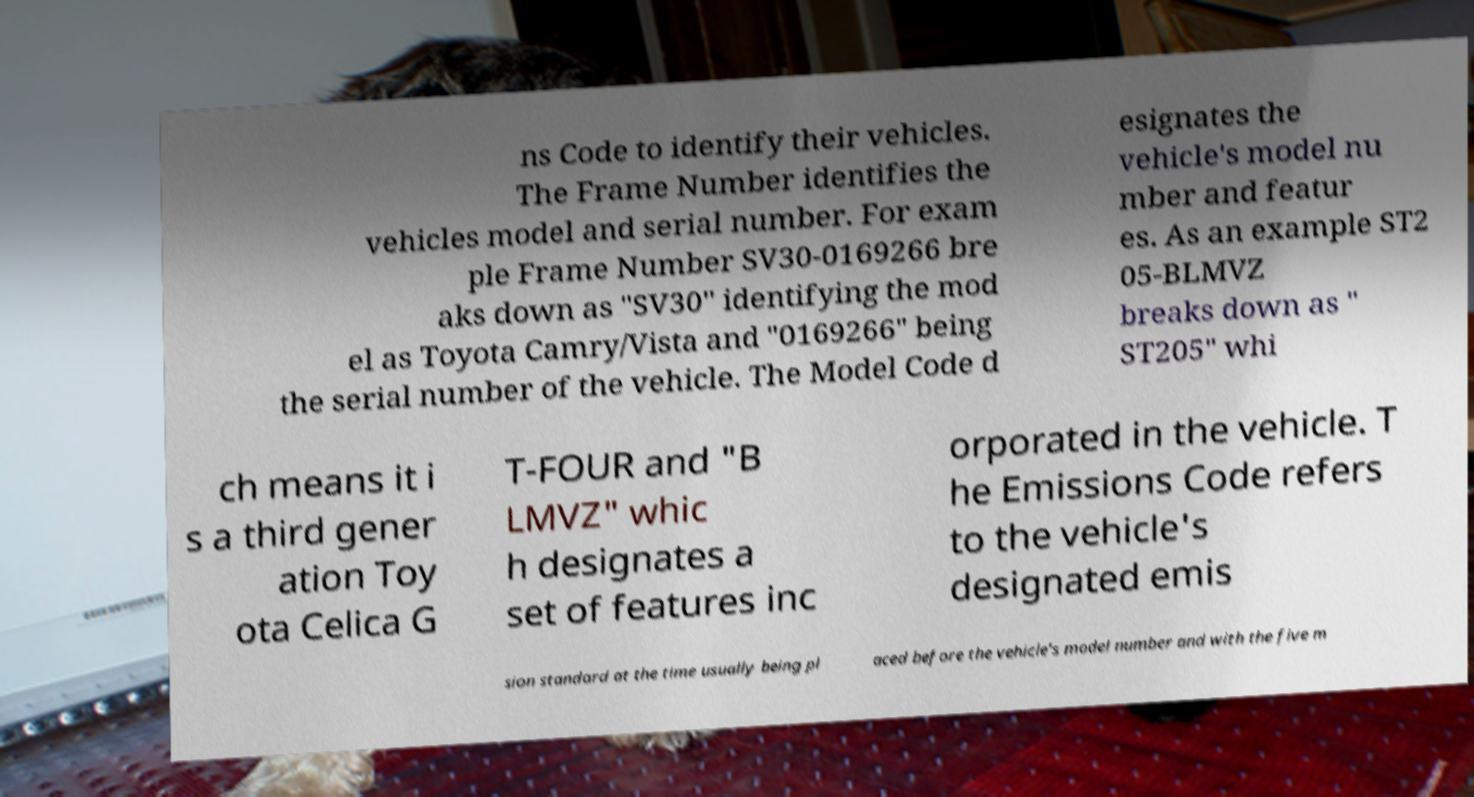What messages or text are displayed in this image? I need them in a readable, typed format. ns Code to identify their vehicles. The Frame Number identifies the vehicles model and serial number. For exam ple Frame Number SV30-0169266 bre aks down as "SV30" identifying the mod el as Toyota Camry/Vista and "0169266" being the serial number of the vehicle. The Model Code d esignates the vehicle's model nu mber and featur es. As an example ST2 05-BLMVZ breaks down as " ST205" whi ch means it i s a third gener ation Toy ota Celica G T-FOUR and "B LMVZ" whic h designates a set of features inc orporated in the vehicle. T he Emissions Code refers to the vehicle's designated emis sion standard at the time usually being pl aced before the vehicle's model number and with the five m 